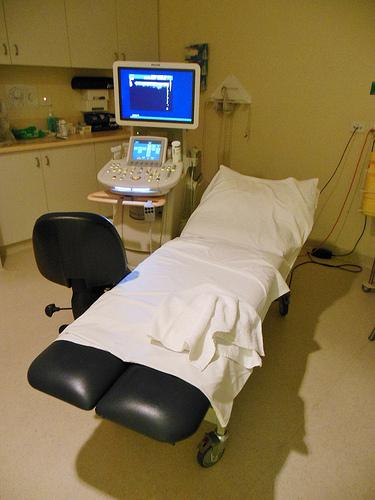Question: where is this place?
Choices:
A. Doctor's office.
B. Nurse's office.
C. Emergency room.
D. Hospital.
Answer with the letter. Answer: D Question: what is under the bed?
Choices:
A. Clothes.
B. Shadows.
C. Socks.
D. Toys.
Answer with the letter. Answer: B Question: why are there shadows?
Choices:
A. Because of reflection.
B. Because of the time of day.
C. Because of the sun.
D. Because of light.
Answer with the letter. Answer: D 